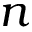<formula> <loc_0><loc_0><loc_500><loc_500>n</formula> 